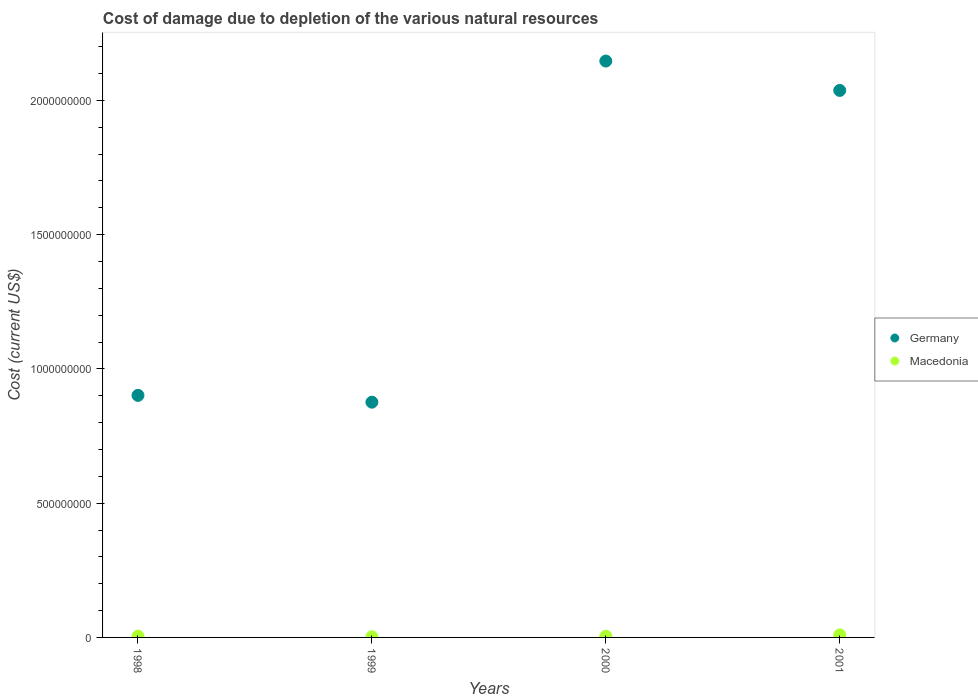How many different coloured dotlines are there?
Provide a succinct answer. 2. Is the number of dotlines equal to the number of legend labels?
Provide a succinct answer. Yes. What is the cost of damage caused due to the depletion of various natural resources in Germany in 2000?
Ensure brevity in your answer.  2.15e+09. Across all years, what is the maximum cost of damage caused due to the depletion of various natural resources in Germany?
Offer a terse response. 2.15e+09. Across all years, what is the minimum cost of damage caused due to the depletion of various natural resources in Macedonia?
Keep it short and to the point. 2.64e+06. In which year was the cost of damage caused due to the depletion of various natural resources in Macedonia maximum?
Provide a succinct answer. 2001. In which year was the cost of damage caused due to the depletion of various natural resources in Germany minimum?
Give a very brief answer. 1999. What is the total cost of damage caused due to the depletion of various natural resources in Germany in the graph?
Ensure brevity in your answer.  5.96e+09. What is the difference between the cost of damage caused due to the depletion of various natural resources in Germany in 1999 and that in 2000?
Give a very brief answer. -1.27e+09. What is the difference between the cost of damage caused due to the depletion of various natural resources in Macedonia in 1998 and the cost of damage caused due to the depletion of various natural resources in Germany in 2000?
Your response must be concise. -2.14e+09. What is the average cost of damage caused due to the depletion of various natural resources in Germany per year?
Make the answer very short. 1.49e+09. In the year 2000, what is the difference between the cost of damage caused due to the depletion of various natural resources in Germany and cost of damage caused due to the depletion of various natural resources in Macedonia?
Provide a short and direct response. 2.14e+09. In how many years, is the cost of damage caused due to the depletion of various natural resources in Macedonia greater than 1700000000 US$?
Provide a succinct answer. 0. What is the ratio of the cost of damage caused due to the depletion of various natural resources in Germany in 2000 to that in 2001?
Your answer should be compact. 1.05. Is the cost of damage caused due to the depletion of various natural resources in Macedonia in 1998 less than that in 2001?
Make the answer very short. Yes. What is the difference between the highest and the second highest cost of damage caused due to the depletion of various natural resources in Macedonia?
Your answer should be compact. 4.61e+06. What is the difference between the highest and the lowest cost of damage caused due to the depletion of various natural resources in Macedonia?
Offer a terse response. 6.93e+06. In how many years, is the cost of damage caused due to the depletion of various natural resources in Germany greater than the average cost of damage caused due to the depletion of various natural resources in Germany taken over all years?
Keep it short and to the point. 2. Is the sum of the cost of damage caused due to the depletion of various natural resources in Macedonia in 1999 and 2000 greater than the maximum cost of damage caused due to the depletion of various natural resources in Germany across all years?
Ensure brevity in your answer.  No. Does the cost of damage caused due to the depletion of various natural resources in Germany monotonically increase over the years?
Offer a very short reply. No. Is the cost of damage caused due to the depletion of various natural resources in Germany strictly greater than the cost of damage caused due to the depletion of various natural resources in Macedonia over the years?
Offer a very short reply. Yes. Is the cost of damage caused due to the depletion of various natural resources in Germany strictly less than the cost of damage caused due to the depletion of various natural resources in Macedonia over the years?
Ensure brevity in your answer.  No. How many years are there in the graph?
Provide a short and direct response. 4. Are the values on the major ticks of Y-axis written in scientific E-notation?
Provide a short and direct response. No. Does the graph contain any zero values?
Your answer should be very brief. No. Where does the legend appear in the graph?
Ensure brevity in your answer.  Center right. How are the legend labels stacked?
Your answer should be compact. Vertical. What is the title of the graph?
Your answer should be compact. Cost of damage due to depletion of the various natural resources. Does "Middle East & North Africa (developing only)" appear as one of the legend labels in the graph?
Your answer should be compact. No. What is the label or title of the Y-axis?
Provide a short and direct response. Cost (current US$). What is the Cost (current US$) of Germany in 1998?
Make the answer very short. 9.02e+08. What is the Cost (current US$) in Macedonia in 1998?
Offer a terse response. 4.96e+06. What is the Cost (current US$) in Germany in 1999?
Ensure brevity in your answer.  8.76e+08. What is the Cost (current US$) in Macedonia in 1999?
Your answer should be compact. 2.64e+06. What is the Cost (current US$) in Germany in 2000?
Ensure brevity in your answer.  2.15e+09. What is the Cost (current US$) of Macedonia in 2000?
Offer a terse response. 4.53e+06. What is the Cost (current US$) of Germany in 2001?
Make the answer very short. 2.04e+09. What is the Cost (current US$) of Macedonia in 2001?
Keep it short and to the point. 9.57e+06. Across all years, what is the maximum Cost (current US$) in Germany?
Your response must be concise. 2.15e+09. Across all years, what is the maximum Cost (current US$) of Macedonia?
Make the answer very short. 9.57e+06. Across all years, what is the minimum Cost (current US$) in Germany?
Give a very brief answer. 8.76e+08. Across all years, what is the minimum Cost (current US$) in Macedonia?
Make the answer very short. 2.64e+06. What is the total Cost (current US$) of Germany in the graph?
Ensure brevity in your answer.  5.96e+09. What is the total Cost (current US$) in Macedonia in the graph?
Your response must be concise. 2.17e+07. What is the difference between the Cost (current US$) of Germany in 1998 and that in 1999?
Offer a very short reply. 2.54e+07. What is the difference between the Cost (current US$) of Macedonia in 1998 and that in 1999?
Offer a terse response. 2.32e+06. What is the difference between the Cost (current US$) of Germany in 1998 and that in 2000?
Your answer should be compact. -1.25e+09. What is the difference between the Cost (current US$) of Macedonia in 1998 and that in 2000?
Give a very brief answer. 4.35e+05. What is the difference between the Cost (current US$) in Germany in 1998 and that in 2001?
Give a very brief answer. -1.14e+09. What is the difference between the Cost (current US$) of Macedonia in 1998 and that in 2001?
Your response must be concise. -4.61e+06. What is the difference between the Cost (current US$) in Germany in 1999 and that in 2000?
Your answer should be compact. -1.27e+09. What is the difference between the Cost (current US$) in Macedonia in 1999 and that in 2000?
Make the answer very short. -1.89e+06. What is the difference between the Cost (current US$) of Germany in 1999 and that in 2001?
Give a very brief answer. -1.16e+09. What is the difference between the Cost (current US$) in Macedonia in 1999 and that in 2001?
Keep it short and to the point. -6.93e+06. What is the difference between the Cost (current US$) in Germany in 2000 and that in 2001?
Keep it short and to the point. 1.09e+08. What is the difference between the Cost (current US$) in Macedonia in 2000 and that in 2001?
Provide a short and direct response. -5.05e+06. What is the difference between the Cost (current US$) of Germany in 1998 and the Cost (current US$) of Macedonia in 1999?
Give a very brief answer. 8.99e+08. What is the difference between the Cost (current US$) of Germany in 1998 and the Cost (current US$) of Macedonia in 2000?
Make the answer very short. 8.97e+08. What is the difference between the Cost (current US$) in Germany in 1998 and the Cost (current US$) in Macedonia in 2001?
Provide a short and direct response. 8.92e+08. What is the difference between the Cost (current US$) of Germany in 1999 and the Cost (current US$) of Macedonia in 2000?
Provide a short and direct response. 8.72e+08. What is the difference between the Cost (current US$) in Germany in 1999 and the Cost (current US$) in Macedonia in 2001?
Offer a terse response. 8.67e+08. What is the difference between the Cost (current US$) in Germany in 2000 and the Cost (current US$) in Macedonia in 2001?
Offer a terse response. 2.14e+09. What is the average Cost (current US$) in Germany per year?
Offer a terse response. 1.49e+09. What is the average Cost (current US$) in Macedonia per year?
Your answer should be very brief. 5.42e+06. In the year 1998, what is the difference between the Cost (current US$) in Germany and Cost (current US$) in Macedonia?
Your answer should be compact. 8.97e+08. In the year 1999, what is the difference between the Cost (current US$) in Germany and Cost (current US$) in Macedonia?
Keep it short and to the point. 8.74e+08. In the year 2000, what is the difference between the Cost (current US$) of Germany and Cost (current US$) of Macedonia?
Your answer should be very brief. 2.14e+09. In the year 2001, what is the difference between the Cost (current US$) in Germany and Cost (current US$) in Macedonia?
Provide a short and direct response. 2.03e+09. What is the ratio of the Cost (current US$) of Germany in 1998 to that in 1999?
Offer a terse response. 1.03. What is the ratio of the Cost (current US$) in Macedonia in 1998 to that in 1999?
Offer a terse response. 1.88. What is the ratio of the Cost (current US$) of Germany in 1998 to that in 2000?
Provide a short and direct response. 0.42. What is the ratio of the Cost (current US$) of Macedonia in 1998 to that in 2000?
Ensure brevity in your answer.  1.1. What is the ratio of the Cost (current US$) in Germany in 1998 to that in 2001?
Your answer should be very brief. 0.44. What is the ratio of the Cost (current US$) of Macedonia in 1998 to that in 2001?
Keep it short and to the point. 0.52. What is the ratio of the Cost (current US$) of Germany in 1999 to that in 2000?
Ensure brevity in your answer.  0.41. What is the ratio of the Cost (current US$) of Macedonia in 1999 to that in 2000?
Keep it short and to the point. 0.58. What is the ratio of the Cost (current US$) in Germany in 1999 to that in 2001?
Keep it short and to the point. 0.43. What is the ratio of the Cost (current US$) in Macedonia in 1999 to that in 2001?
Offer a terse response. 0.28. What is the ratio of the Cost (current US$) of Germany in 2000 to that in 2001?
Your response must be concise. 1.05. What is the ratio of the Cost (current US$) of Macedonia in 2000 to that in 2001?
Your answer should be very brief. 0.47. What is the difference between the highest and the second highest Cost (current US$) of Germany?
Provide a succinct answer. 1.09e+08. What is the difference between the highest and the second highest Cost (current US$) of Macedonia?
Your answer should be compact. 4.61e+06. What is the difference between the highest and the lowest Cost (current US$) in Germany?
Provide a short and direct response. 1.27e+09. What is the difference between the highest and the lowest Cost (current US$) in Macedonia?
Your answer should be compact. 6.93e+06. 